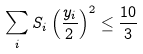Convert formula to latex. <formula><loc_0><loc_0><loc_500><loc_500>\sum _ { i } S _ { i } \left ( \frac { y _ { i } } { 2 } \right ) ^ { 2 } \leq \frac { 1 0 } { 3 }</formula> 